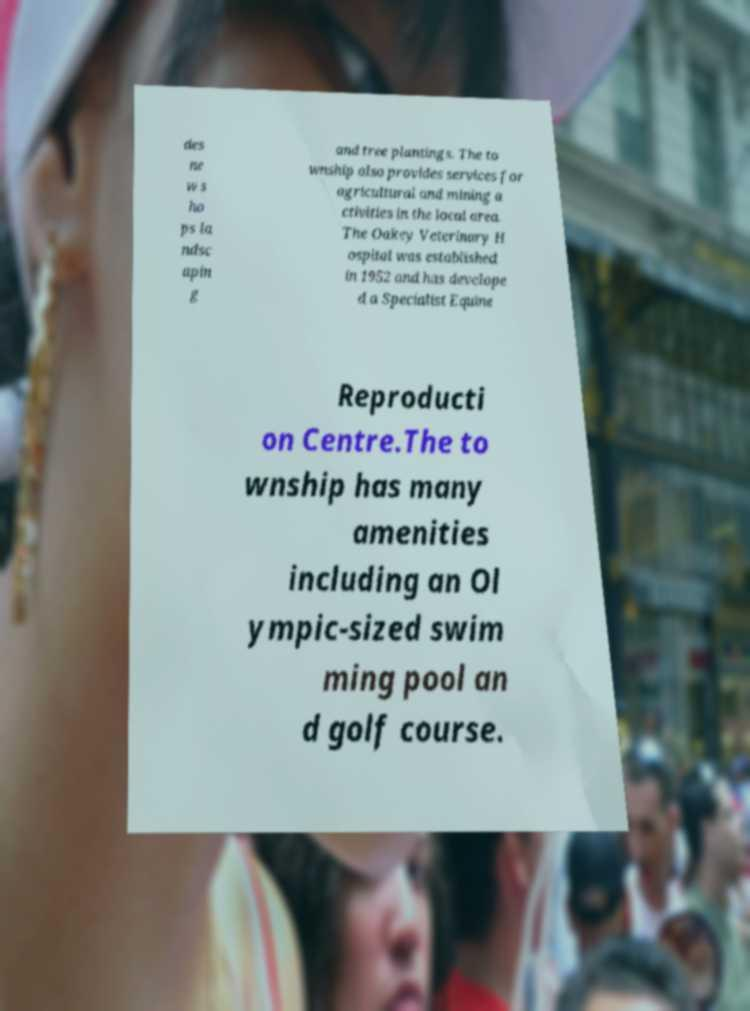Can you accurately transcribe the text from the provided image for me? des ne w s ho ps la ndsc apin g and tree plantings. The to wnship also provides services for agricultural and mining a ctivities in the local area. The Oakey Veterinary H ospital was established in 1952 and has develope d a Specialist Equine Reproducti on Centre.The to wnship has many amenities including an Ol ympic-sized swim ming pool an d golf course. 